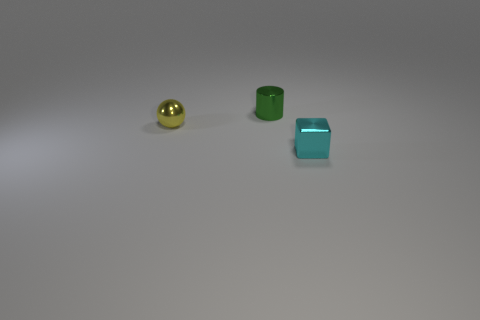Is the number of tiny metallic balls behind the green cylinder the same as the number of tiny balls to the left of the small yellow ball?
Your answer should be compact. Yes. There is a green shiny object; does it have the same size as the metal object right of the small green metallic cylinder?
Offer a terse response. Yes. Are there more tiny metallic objects that are in front of the green cylinder than small metallic balls?
Provide a succinct answer. Yes. How many cyan cubes are the same size as the ball?
Make the answer very short. 1. Is the size of the object that is on the left side of the green cylinder the same as the metal thing that is behind the small metal ball?
Your answer should be very brief. Yes. Is the number of metallic objects that are in front of the small cyan metal cube greater than the number of blocks behind the green shiny cylinder?
Offer a very short reply. No. What number of other small metal things have the same shape as the cyan metal object?
Offer a terse response. 0. There is a green thing that is the same size as the metal ball; what is its material?
Your answer should be compact. Metal. Is there another green cylinder made of the same material as the green cylinder?
Your response must be concise. No. Is the number of tiny yellow objects that are right of the yellow sphere less than the number of purple rubber cubes?
Provide a short and direct response. No. 